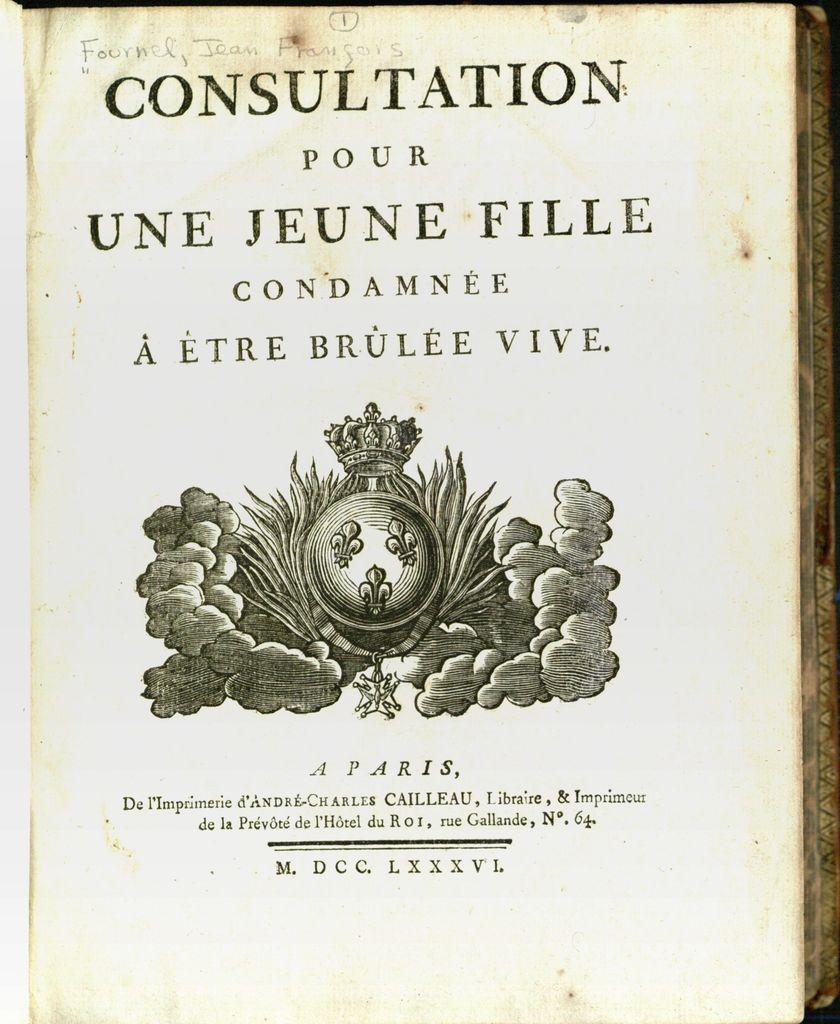Provide a one-sentence caption for the provided image. an old book callecd consultation pour une jeune. 